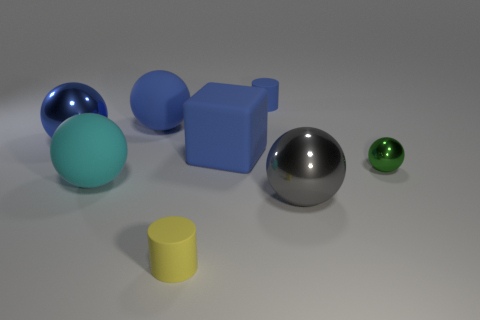The metal object that is the same color as the large matte block is what shape?
Make the answer very short. Sphere. How many other objects are the same material as the small green ball?
Your answer should be very brief. 2. Are there any gray metal balls to the left of the big cyan sphere?
Give a very brief answer. No. There is a blue shiny thing; is it the same size as the cylinder behind the tiny yellow rubber cylinder?
Offer a terse response. No. There is a big metallic thing in front of the large shiny ball that is to the left of the yellow thing; what color is it?
Give a very brief answer. Gray. Is the size of the blue cylinder the same as the cyan object?
Your answer should be very brief. No. There is a metal object that is left of the small green object and behind the large gray sphere; what is its color?
Your answer should be very brief. Blue. What size is the gray ball?
Keep it short and to the point. Large. Does the large metal thing that is in front of the big blue metallic ball have the same color as the cube?
Offer a very short reply. No. Are there more big blue balls in front of the big cube than large blue shiny things that are on the right side of the small blue rubber cylinder?
Ensure brevity in your answer.  No. 